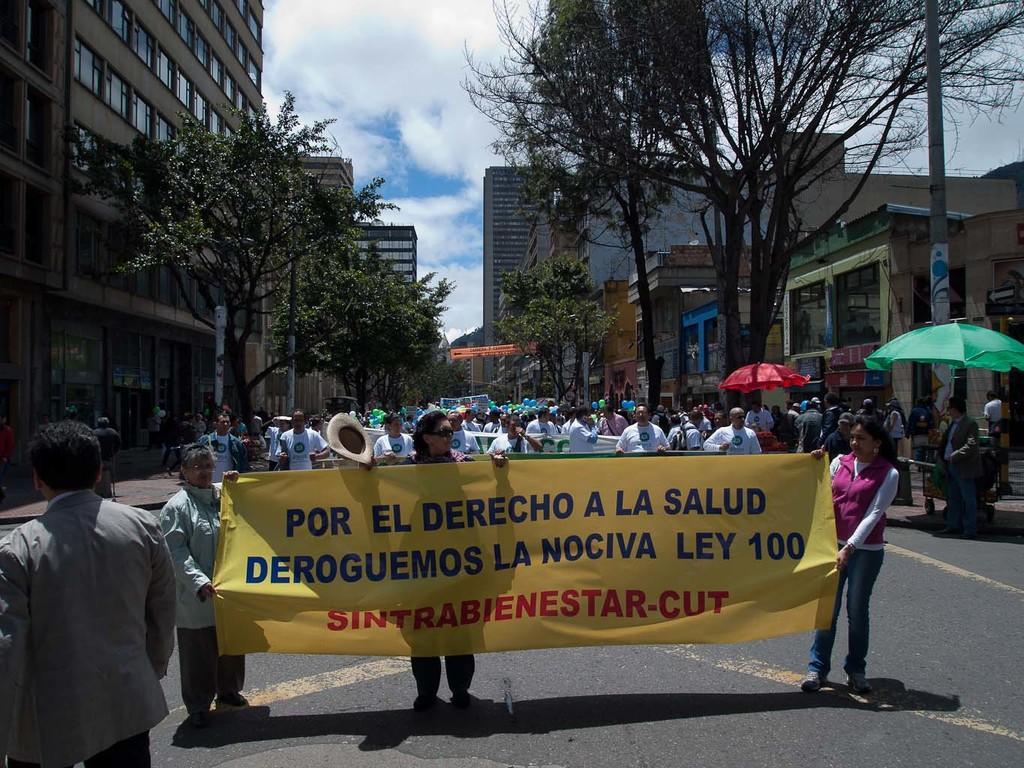Describe this image in one or two sentences. In this image we can see three women holding a banner on the road. We can also see a crowd back to them. We can also see some buildings with windows, trees, pole, banner, umbrellas and the sky which looks cloudy. 